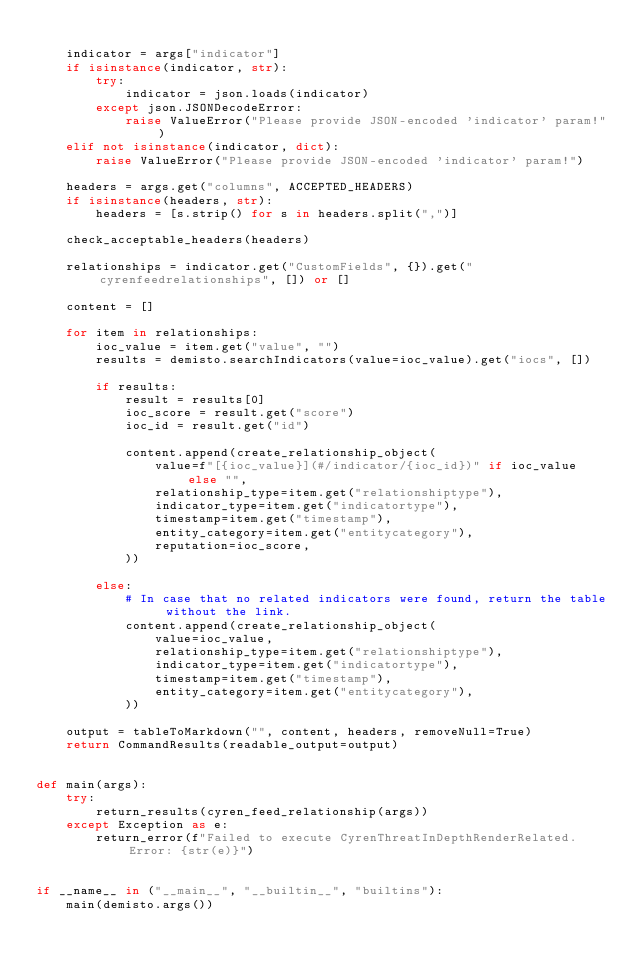Convert code to text. <code><loc_0><loc_0><loc_500><loc_500><_Python_>
    indicator = args["indicator"]
    if isinstance(indicator, str):
        try:
            indicator = json.loads(indicator)
        except json.JSONDecodeError:
            raise ValueError("Please provide JSON-encoded 'indicator' param!")
    elif not isinstance(indicator, dict):
        raise ValueError("Please provide JSON-encoded 'indicator' param!")

    headers = args.get("columns", ACCEPTED_HEADERS)
    if isinstance(headers, str):
        headers = [s.strip() for s in headers.split(",")]

    check_acceptable_headers(headers)

    relationships = indicator.get("CustomFields", {}).get("cyrenfeedrelationships", []) or []

    content = []

    for item in relationships:
        ioc_value = item.get("value", "")
        results = demisto.searchIndicators(value=ioc_value).get("iocs", [])

        if results:
            result = results[0]
            ioc_score = result.get("score")
            ioc_id = result.get("id")

            content.append(create_relationship_object(
                value=f"[{ioc_value}](#/indicator/{ioc_id})" if ioc_value else "",
                relationship_type=item.get("relationshiptype"),
                indicator_type=item.get("indicatortype"),
                timestamp=item.get("timestamp"),
                entity_category=item.get("entitycategory"),
                reputation=ioc_score,
            ))

        else:
            # In case that no related indicators were found, return the table without the link.
            content.append(create_relationship_object(
                value=ioc_value,
                relationship_type=item.get("relationshiptype"),
                indicator_type=item.get("indicatortype"),
                timestamp=item.get("timestamp"),
                entity_category=item.get("entitycategory"),
            ))

    output = tableToMarkdown("", content, headers, removeNull=True)
    return CommandResults(readable_output=output)


def main(args):
    try:
        return_results(cyren_feed_relationship(args))
    except Exception as e:
        return_error(f"Failed to execute CyrenThreatInDepthRenderRelated. Error: {str(e)}")


if __name__ in ("__main__", "__builtin__", "builtins"):
    main(demisto.args())
</code> 